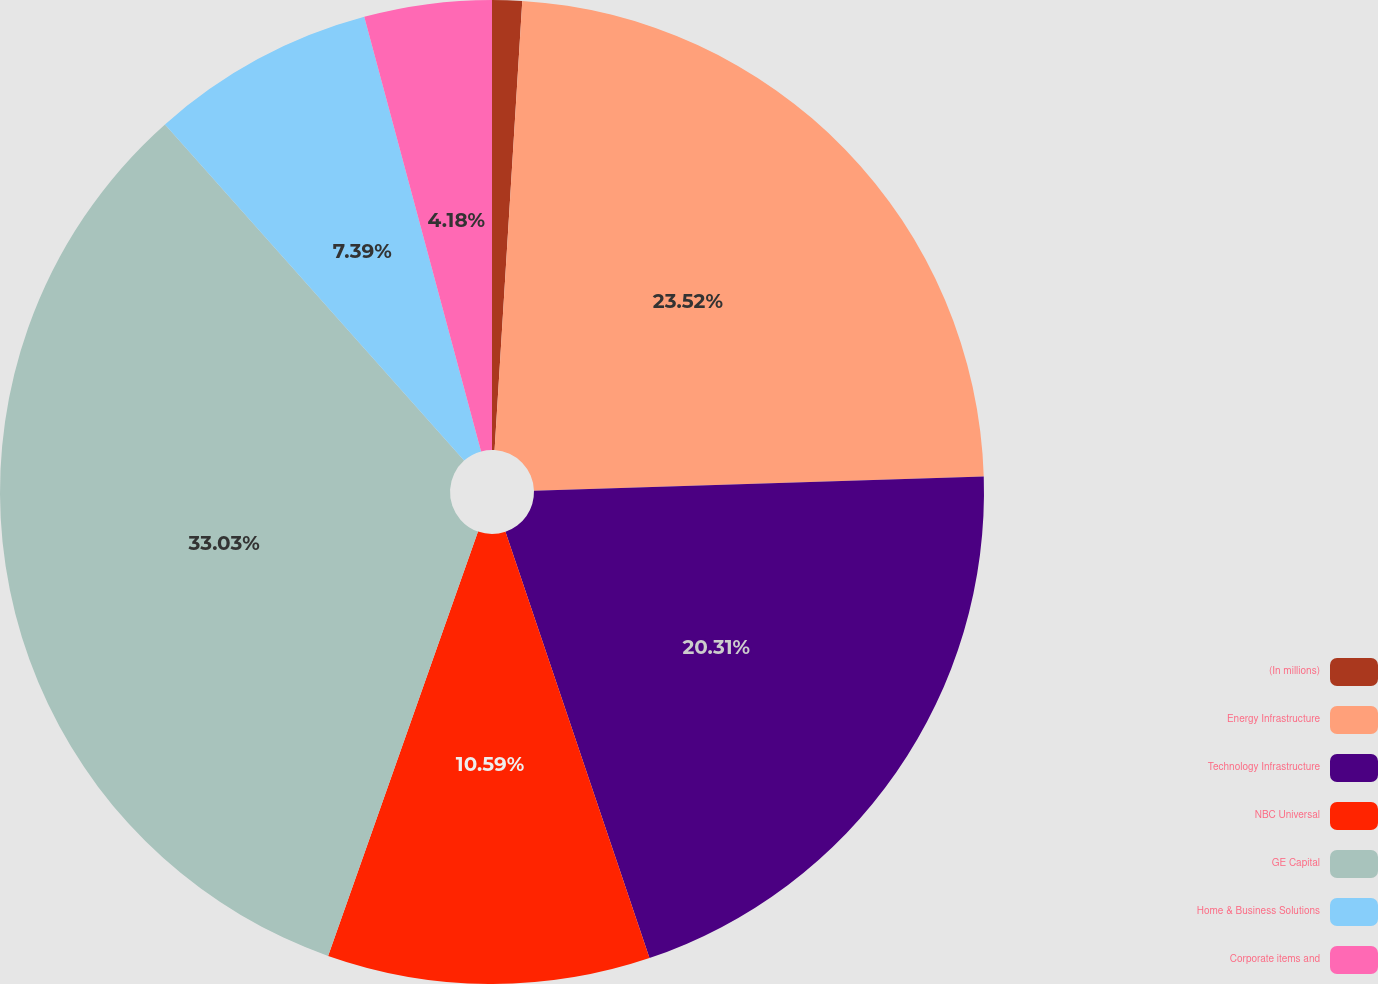Convert chart. <chart><loc_0><loc_0><loc_500><loc_500><pie_chart><fcel>(In millions)<fcel>Energy Infrastructure<fcel>Technology Infrastructure<fcel>NBC Universal<fcel>GE Capital<fcel>Home & Business Solutions<fcel>Corporate items and<nl><fcel>0.98%<fcel>23.52%<fcel>20.31%<fcel>10.59%<fcel>33.02%<fcel>7.39%<fcel>4.18%<nl></chart> 